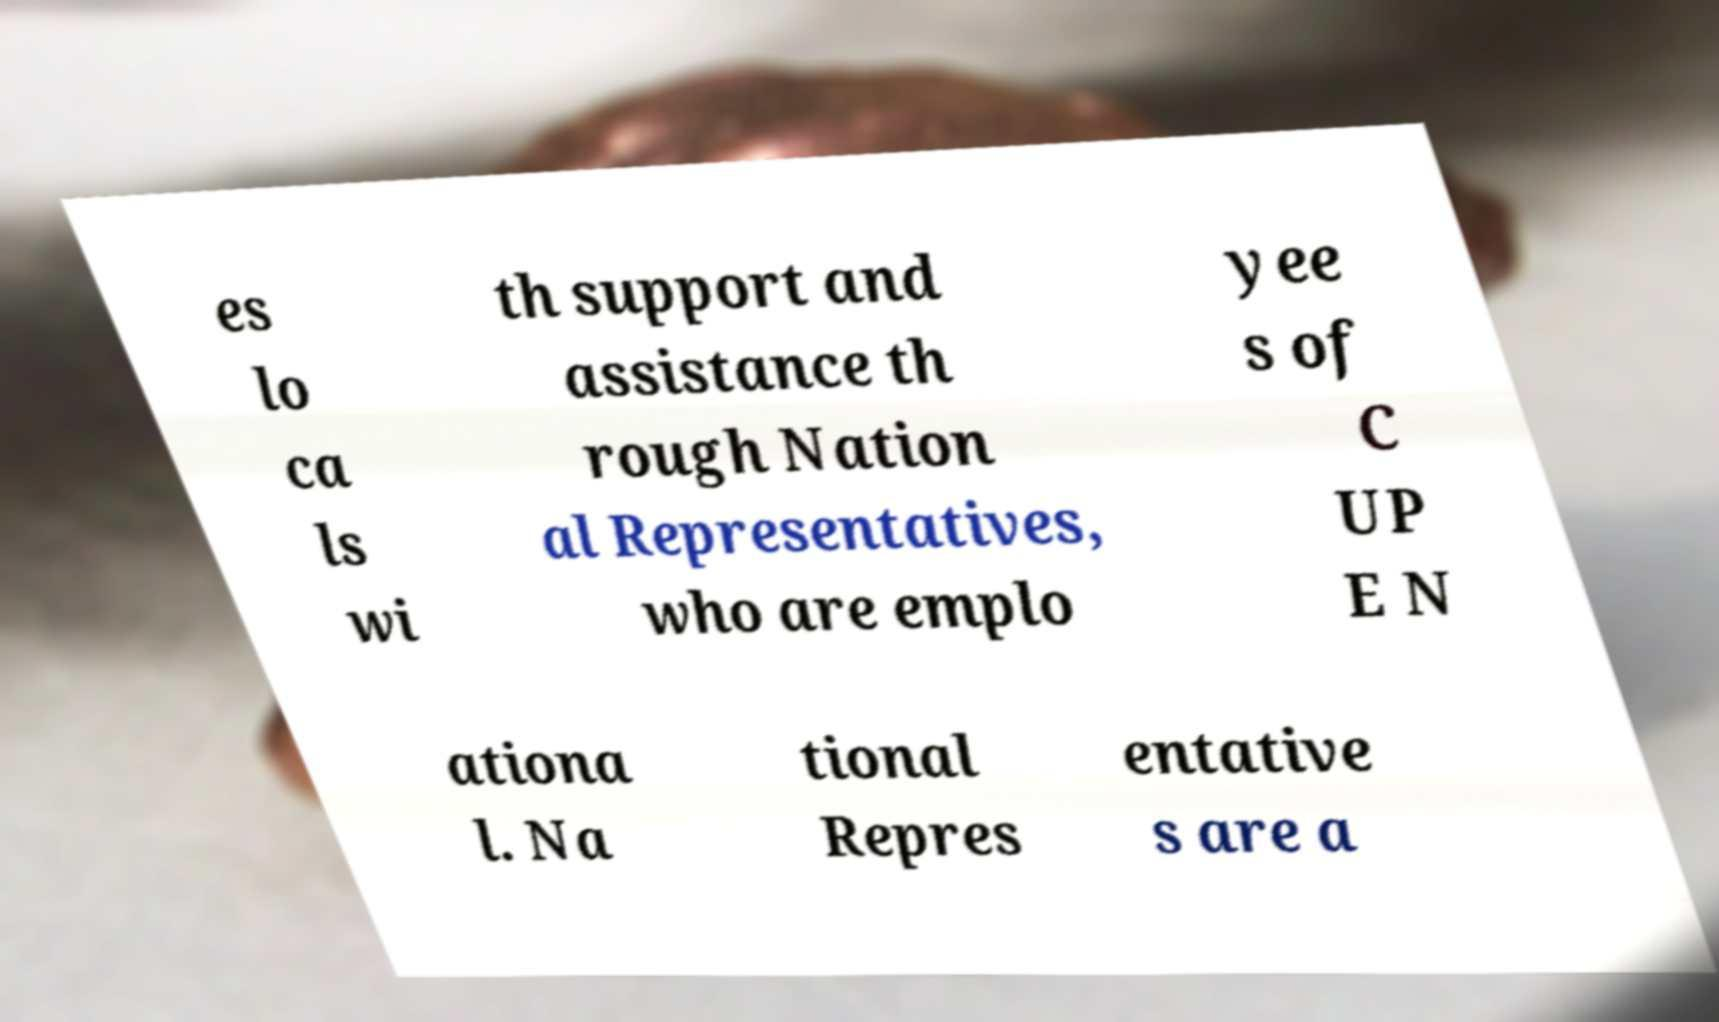Please read and relay the text visible in this image. What does it say? es lo ca ls wi th support and assistance th rough Nation al Representatives, who are emplo yee s of C UP E N ationa l. Na tional Repres entative s are a 